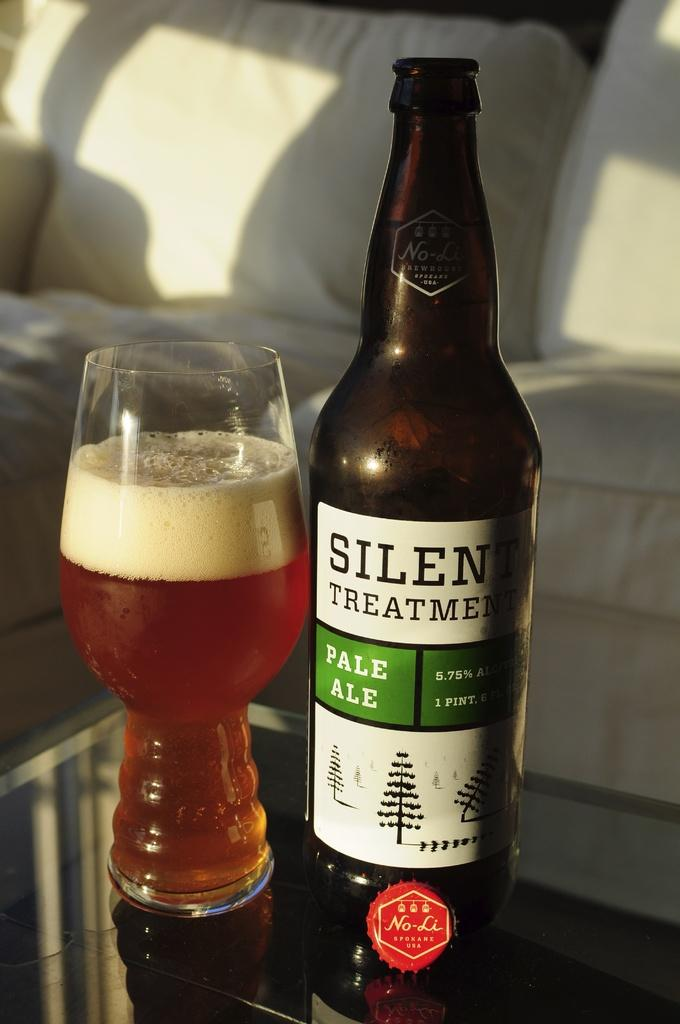<image>
Relay a brief, clear account of the picture shown. A glass of poured pale ale with the original bottle standing beside it on a glass table. 